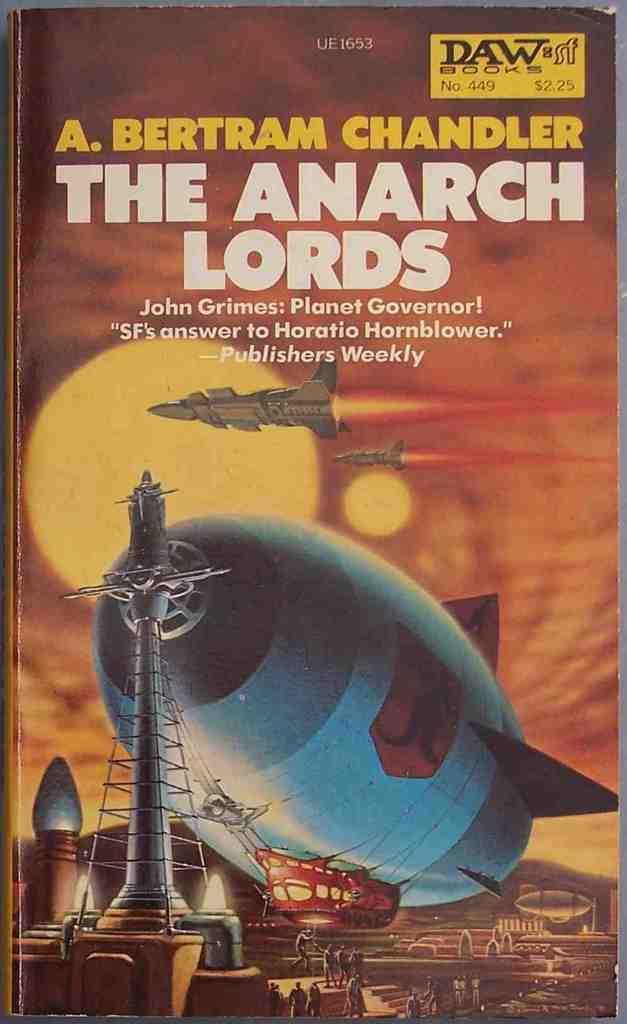What is the title of this book?
Your answer should be compact. The anarch lords. Who wrote this book?
Ensure brevity in your answer.  A. bertram chandler. 